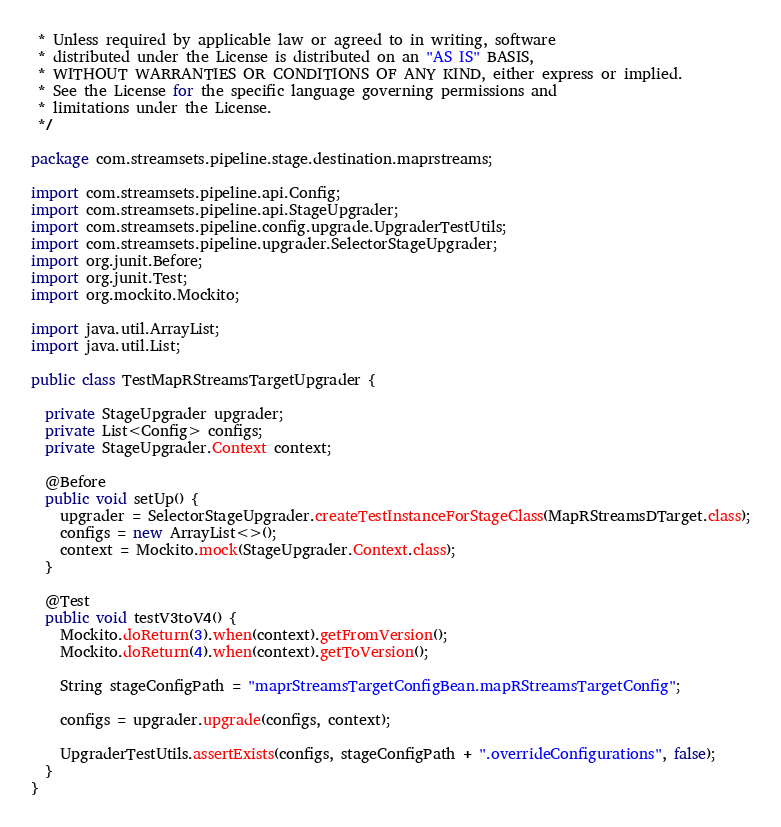<code> <loc_0><loc_0><loc_500><loc_500><_Java_> * Unless required by applicable law or agreed to in writing, software
 * distributed under the License is distributed on an "AS IS" BASIS,
 * WITHOUT WARRANTIES OR CONDITIONS OF ANY KIND, either express or implied.
 * See the License for the specific language governing permissions and
 * limitations under the License.
 */

package com.streamsets.pipeline.stage.destination.maprstreams;

import com.streamsets.pipeline.api.Config;
import com.streamsets.pipeline.api.StageUpgrader;
import com.streamsets.pipeline.config.upgrade.UpgraderTestUtils;
import com.streamsets.pipeline.upgrader.SelectorStageUpgrader;
import org.junit.Before;
import org.junit.Test;
import org.mockito.Mockito;

import java.util.ArrayList;
import java.util.List;

public class TestMapRStreamsTargetUpgrader {

  private StageUpgrader upgrader;
  private List<Config> configs;
  private StageUpgrader.Context context;

  @Before
  public void setUp() {
    upgrader = SelectorStageUpgrader.createTestInstanceForStageClass(MapRStreamsDTarget.class);
    configs = new ArrayList<>();
    context = Mockito.mock(StageUpgrader.Context.class);
  }

  @Test
  public void testV3toV4() {
    Mockito.doReturn(3).when(context).getFromVersion();
    Mockito.doReturn(4).when(context).getToVersion();

    String stageConfigPath = "maprStreamsTargetConfigBean.mapRStreamsTargetConfig";

    configs = upgrader.upgrade(configs, context);

    UpgraderTestUtils.assertExists(configs, stageConfigPath + ".overrideConfigurations", false);
  }
}
</code> 